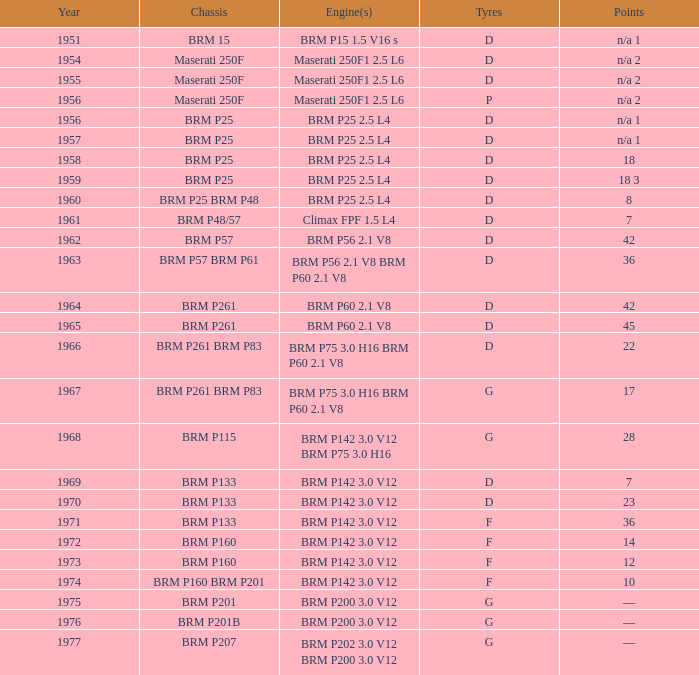0 v12 engines. 1977.0. 